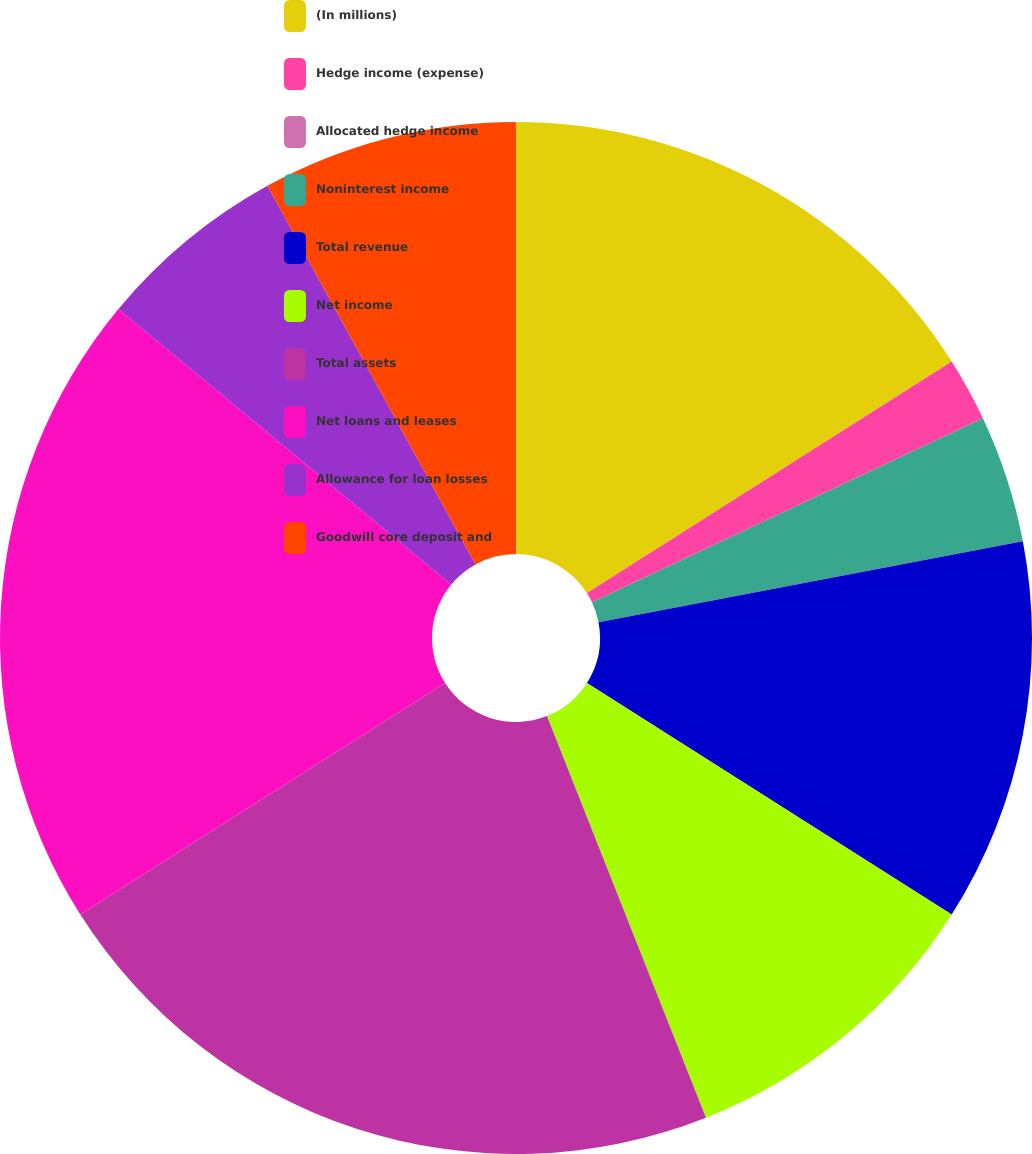Convert chart to OTSL. <chart><loc_0><loc_0><loc_500><loc_500><pie_chart><fcel>(In millions)<fcel>Hedge income (expense)<fcel>Allocated hedge income<fcel>Noninterest income<fcel>Total revenue<fcel>Net income<fcel>Total assets<fcel>Net loans and leases<fcel>Allowance for loan losses<fcel>Goodwill core deposit and<nl><fcel>16.0%<fcel>2.0%<fcel>0.0%<fcel>4.0%<fcel>12.0%<fcel>10.0%<fcel>22.0%<fcel>20.0%<fcel>6.0%<fcel>8.0%<nl></chart> 